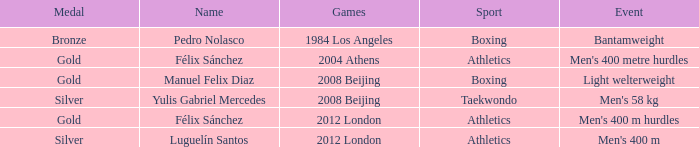In the 2012 london games, which medal did félix sánchez win? Gold. 